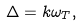<formula> <loc_0><loc_0><loc_500><loc_500>\Delta = k \omega _ { T } ,</formula> 